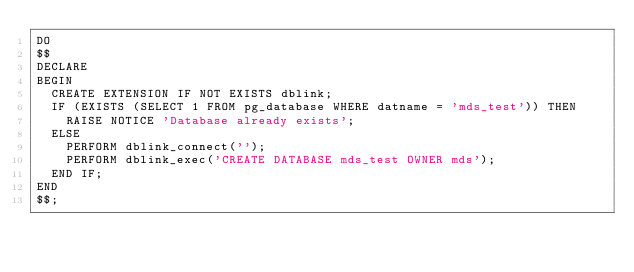<code> <loc_0><loc_0><loc_500><loc_500><_SQL_>DO
$$
DECLARE
BEGIN
  CREATE EXTENSION IF NOT EXISTS dblink;
  IF (EXISTS (SELECT 1 FROM pg_database WHERE datname = 'mds_test')) THEN
    RAISE NOTICE 'Database already exists';
  ELSE
    PERFORM dblink_connect('');
    PERFORM dblink_exec('CREATE DATABASE mds_test OWNER mds');
  END IF;
END
$$;</code> 